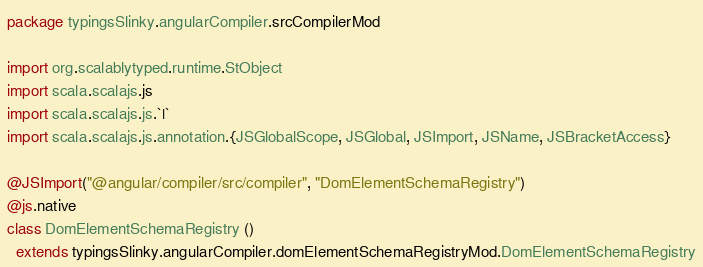<code> <loc_0><loc_0><loc_500><loc_500><_Scala_>package typingsSlinky.angularCompiler.srcCompilerMod

import org.scalablytyped.runtime.StObject
import scala.scalajs.js
import scala.scalajs.js.`|`
import scala.scalajs.js.annotation.{JSGlobalScope, JSGlobal, JSImport, JSName, JSBracketAccess}

@JSImport("@angular/compiler/src/compiler", "DomElementSchemaRegistry")
@js.native
class DomElementSchemaRegistry ()
  extends typingsSlinky.angularCompiler.domElementSchemaRegistryMod.DomElementSchemaRegistry
</code> 